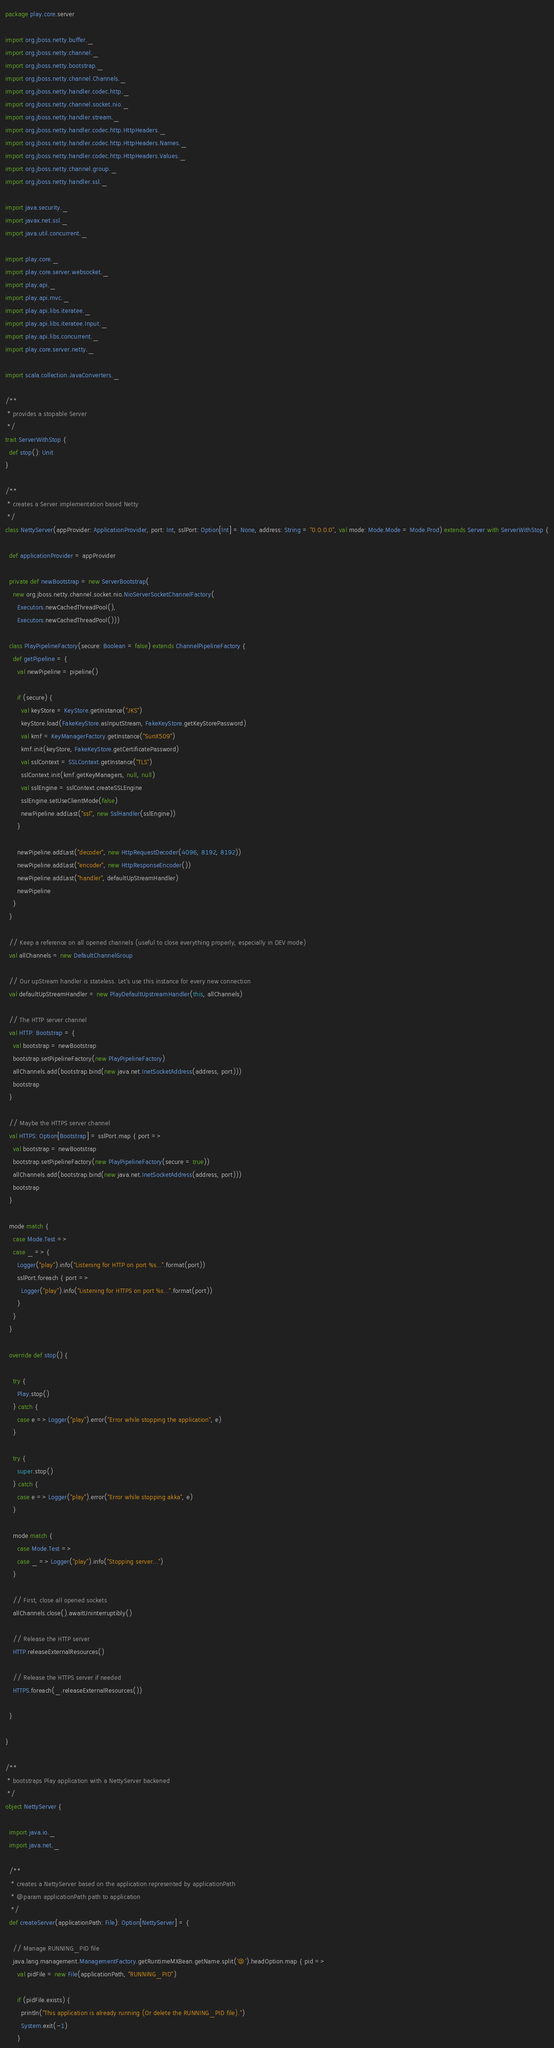Convert code to text. <code><loc_0><loc_0><loc_500><loc_500><_Scala_>package play.core.server

import org.jboss.netty.buffer._
import org.jboss.netty.channel._
import org.jboss.netty.bootstrap._
import org.jboss.netty.channel.Channels._
import org.jboss.netty.handler.codec.http._
import org.jboss.netty.channel.socket.nio._
import org.jboss.netty.handler.stream._
import org.jboss.netty.handler.codec.http.HttpHeaders._
import org.jboss.netty.handler.codec.http.HttpHeaders.Names._
import org.jboss.netty.handler.codec.http.HttpHeaders.Values._
import org.jboss.netty.channel.group._
import org.jboss.netty.handler.ssl._

import java.security._
import javax.net.ssl._
import java.util.concurrent._

import play.core._
import play.core.server.websocket._
import play.api._
import play.api.mvc._
import play.api.libs.iteratee._
import play.api.libs.iteratee.Input._
import play.api.libs.concurrent._
import play.core.server.netty._

import scala.collection.JavaConverters._

/**
 * provides a stopable Server
 */
trait ServerWithStop {
  def stop(): Unit
}

/**
 * creates a Server implementation based Netty
 */
class NettyServer(appProvider: ApplicationProvider, port: Int, sslPort: Option[Int] = None, address: String = "0.0.0.0", val mode: Mode.Mode = Mode.Prod) extends Server with ServerWithStop {

  def applicationProvider = appProvider

  private def newBootstrap = new ServerBootstrap(
    new org.jboss.netty.channel.socket.nio.NioServerSocketChannelFactory(
      Executors.newCachedThreadPool(),
      Executors.newCachedThreadPool()))

  class PlayPipelineFactory(secure: Boolean = false) extends ChannelPipelineFactory {
    def getPipeline = {
      val newPipeline = pipeline()

      if (secure) {
        val keyStore = KeyStore.getInstance("JKS")
        keyStore.load(FakeKeyStore.asInputStream, FakeKeyStore.getKeyStorePassword)
        val kmf = KeyManagerFactory.getInstance("SunX509")
        kmf.init(keyStore, FakeKeyStore.getCertificatePassword)
        val sslContext = SSLContext.getInstance("TLS")
        sslContext.init(kmf.getKeyManagers, null, null)
        val sslEngine = sslContext.createSSLEngine
        sslEngine.setUseClientMode(false)
        newPipeline.addLast("ssl", new SslHandler(sslEngine))
      }

      newPipeline.addLast("decoder", new HttpRequestDecoder(4096, 8192, 8192))
      newPipeline.addLast("encoder", new HttpResponseEncoder())
      newPipeline.addLast("handler", defaultUpStreamHandler)
      newPipeline
    }
  }

  // Keep a reference on all opened channels (useful to close everything properly, especially in DEV mode)
  val allChannels = new DefaultChannelGroup

  // Our upStream handler is stateless. Let's use this instance for every new connection
  val defaultUpStreamHandler = new PlayDefaultUpstreamHandler(this, allChannels)

  // The HTTP server channel
  val HTTP: Bootstrap = {
    val bootstrap = newBootstrap
    bootstrap.setPipelineFactory(new PlayPipelineFactory)
    allChannels.add(bootstrap.bind(new java.net.InetSocketAddress(address, port)))
    bootstrap
  }

  // Maybe the HTTPS server channel
  val HTTPS: Option[Bootstrap] = sslPort.map { port =>
    val bootstrap = newBootstrap
    bootstrap.setPipelineFactory(new PlayPipelineFactory(secure = true))
    allChannels.add(bootstrap.bind(new java.net.InetSocketAddress(address, port)))
    bootstrap
  }

  mode match {
    case Mode.Test =>
    case _ => {
      Logger("play").info("Listening for HTTP on port %s...".format(port))
      sslPort.foreach { port =>
        Logger("play").info("Listening for HTTPS on port %s...".format(port))
      }
    }
  }

  override def stop() {

    try {
      Play.stop()
    } catch {
      case e => Logger("play").error("Error while stopping the application", e)
    }

    try {
      super.stop()
    } catch {
      case e => Logger("play").error("Error while stopping akka", e)
    }

    mode match {
      case Mode.Test =>
      case _ => Logger("play").info("Stopping server...")
    }

    // First, close all opened sockets
    allChannels.close().awaitUninterruptibly()

    // Release the HTTP server
    HTTP.releaseExternalResources()

    // Release the HTTPS server if needed
    HTTPS.foreach(_.releaseExternalResources())

  }

}

/**
 * bootstraps Play application with a NettyServer backened
 */
object NettyServer {

  import java.io._
  import java.net._

  /**
   * creates a NettyServer based on the application represented by applicationPath
   * @param applicationPath path to application
   */
  def createServer(applicationPath: File): Option[NettyServer] = {

    // Manage RUNNING_PID file
    java.lang.management.ManagementFactory.getRuntimeMXBean.getName.split('@').headOption.map { pid =>
      val pidFile = new File(applicationPath, "RUNNING_PID")

      if (pidFile.exists) {
        println("This application is already running (Or delete the RUNNING_PID file).")
        System.exit(-1)
      }
</code> 